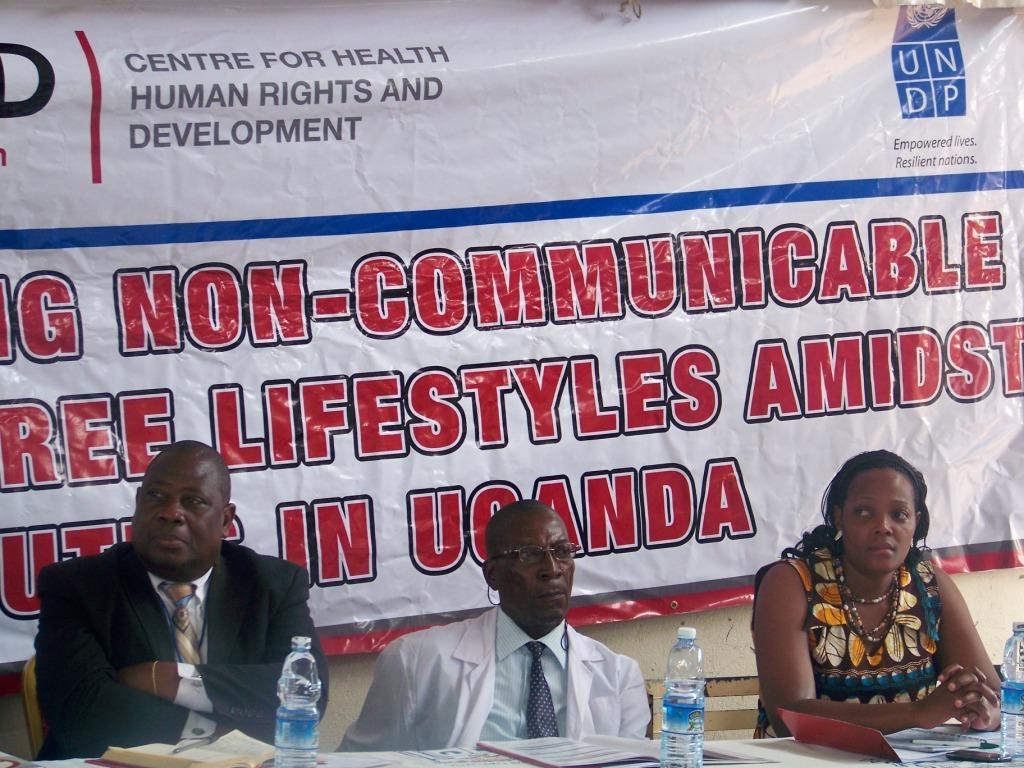Describe this image in one or two sentences. At the bottom of the image we can see three people sitting, before them there is a table and we can see bottles, books and a mobile placed on the table. In the background there is a banner and a wall. 